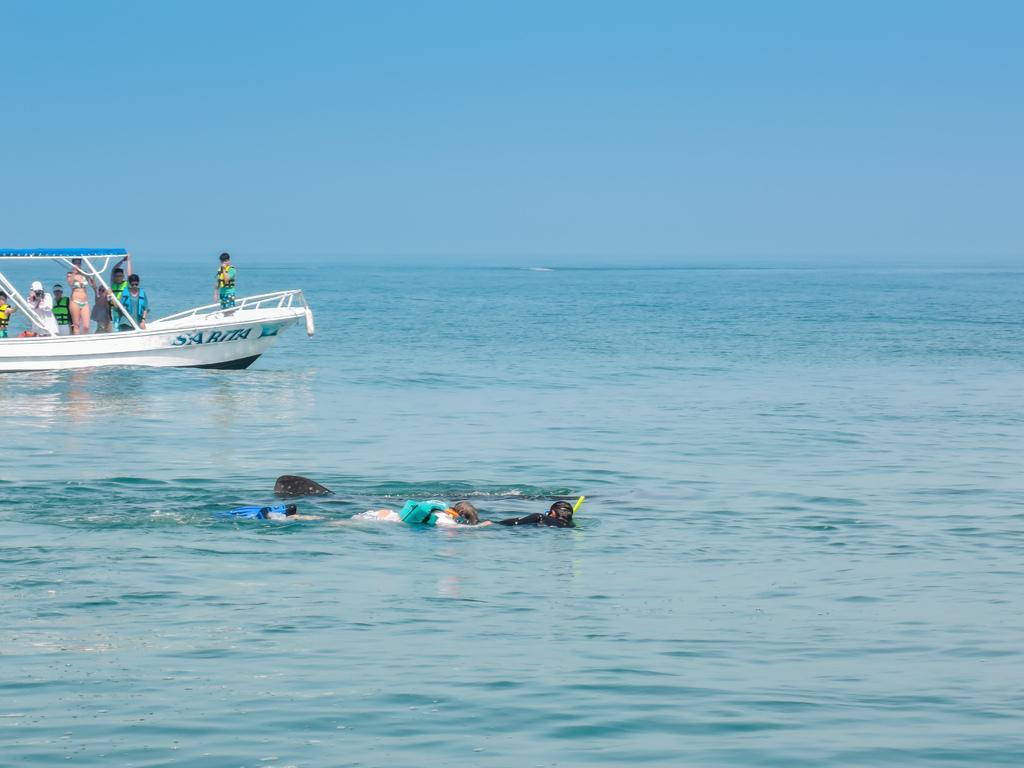Can you describe this image briefly? In this image we can see a boat on a water and there are some people in a boat. We can also see some people are swimming. 